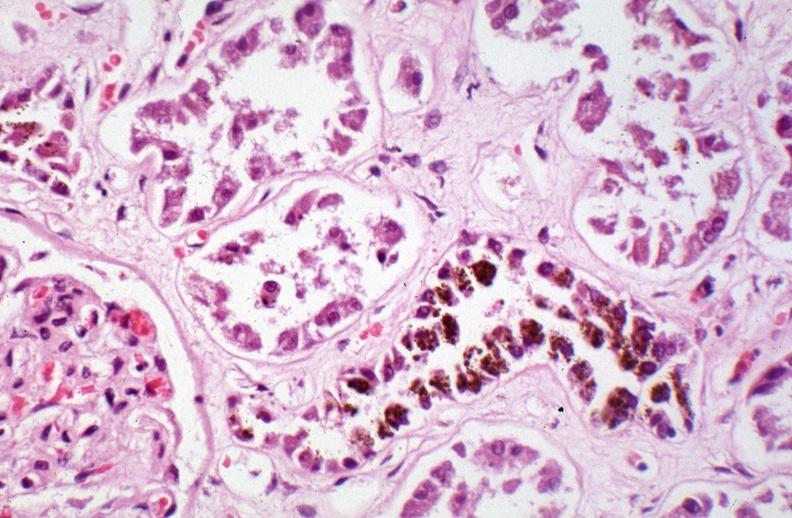s hemosiderosis caused by numerous blood transfusions?
Answer the question using a single word or phrase. Yes 